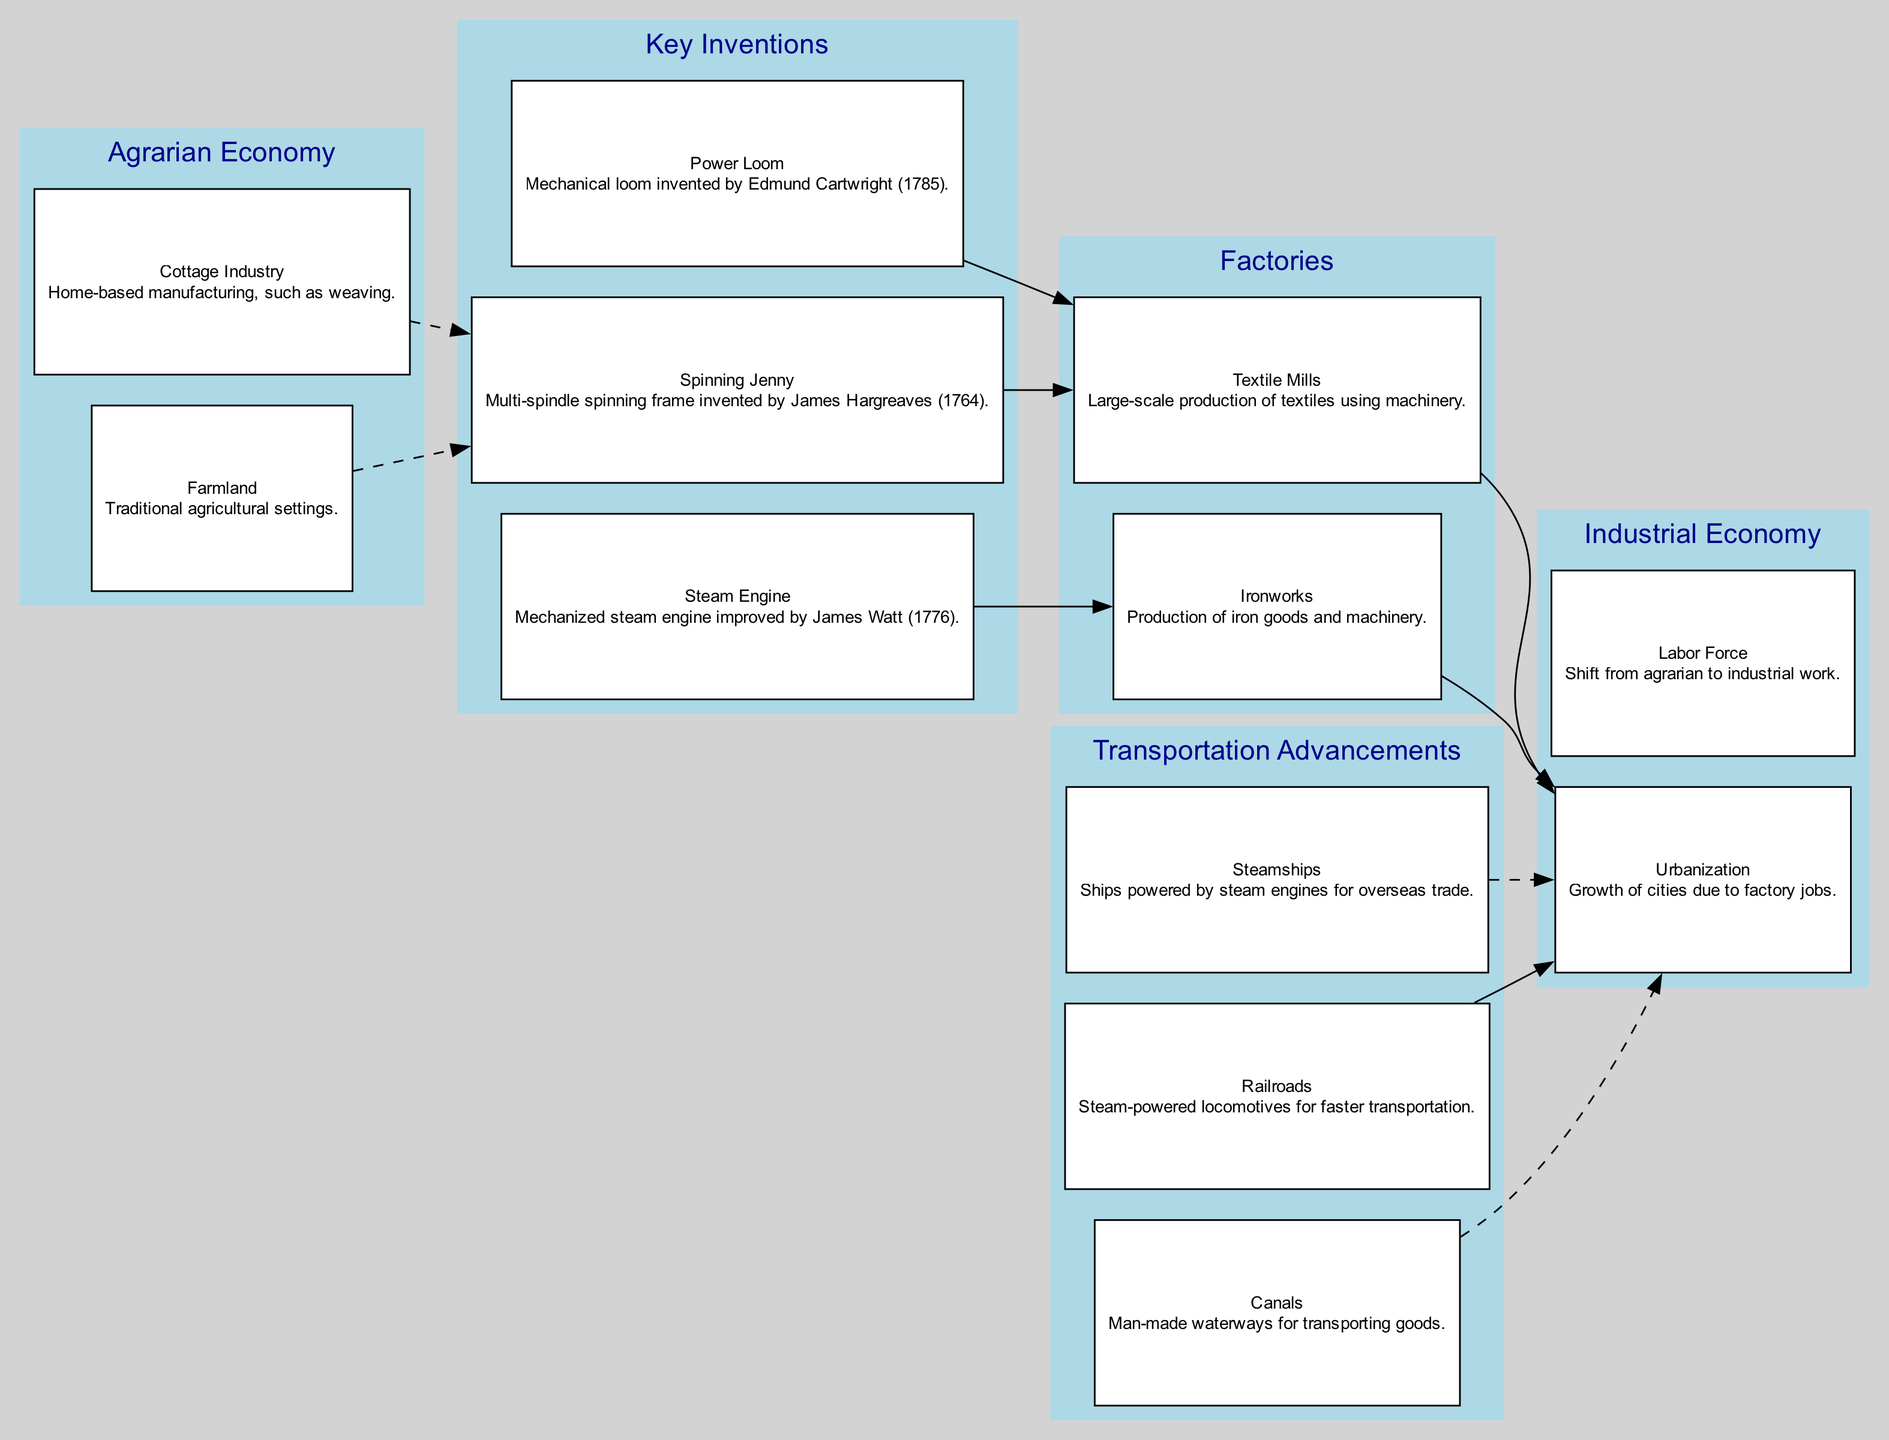What are the two elements under the Agrarian Economy category? According to the diagram, the Agrarian Economy category contains two elements: Farmland, which refers to traditional agricultural settings, and Cottage Industry, which pertains to home-based manufacturing, such as weaving.
Answer: Farmland, Cottage Industry What invention was improved by James Watt in 1776? The diagram indicates that the Steam Engine was the invention improved by James Watt in 1776, as it is explicitly stated in the Key Inventions category.
Answer: Steam Engine How many nodes are present in the Key Inventions category? In the Key Inventions category of the diagram, there are three specific nodes: Spinning Jenny, Steam Engine, and Power Loom. By counting them, the total comes to three nodes.
Answer: 3 Which transportation advancement is linked directly to Urbanization? The diagram shows that Railroads are intricately connected to Urbanization, as they facilitate the movement of people and goods into urban areas, and are depicted with a solid line connecting them in the diagram.
Answer: Railroads What is the relationship between the Power Loom and Textile Mills? The diagram illustrates that the Power Loom is directly connected to Textile Mills, indicating that the Power Loom contributes to the production processes occurring within the Textile Mills as represented by a solid line from Power Loom to Textile Mills.
Answer: Power Loom contributes to Textile Mills Which two elements represent the shift from agrarian to industrial work in the Industrial Economy category? The Industrial Economy category highlights two key elements that signify the shift from agrarian to industrial work: Urbanization, which relates to the growth of cities due to factory jobs, and Labor Force, which denotes the transition from agrarian to industrial employment, showing how societal structures evolved.
Answer: Urbanization, Labor Force What major transportation advancements are mentioned in the diagram? The diagram lists several transportation advancements which include Canals, Railroads, and Steamships. These advancements are crucial for the transportation of goods and people during the Industrial Revolution, thus connecting them to economic growth and urbanization.
Answer: Canals, Railroads, Steamships What key transition is indicated by a dashed line from Cottage Industry? The dashed line from Cottage Industry leads to the Spinning Jenny, indicating that the Cottage Industry serves as a precursor or a foundational element that eventually connects to the innovation of the Spinning Jenny, which marks a transition in textile manufacturing.
Answer: Spinning Jenny How do Textile Mills relate to Urbanization? The diagram demonstrates a direct connection between Textile Mills and Urbanization, showing that the establishment and expansion of Textile Mills led to the growth of urban areas as people moved to cities for jobs in these factories, thereby linking economic activity with demographic changes.
Answer: Textile Mills lead to Urbanization 